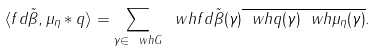Convert formula to latex. <formula><loc_0><loc_0><loc_500><loc_500>\langle f d \tilde { \beta } , \mu _ { \eta } \ast q \rangle = \sum _ { \gamma \in \ w h { G } } { \ w h { f d \tilde { \beta } } ( \gamma ) \overline { \ w h { q } ( \gamma ) \ w h { \mu _ { \eta } } ( \gamma ) } } .</formula> 